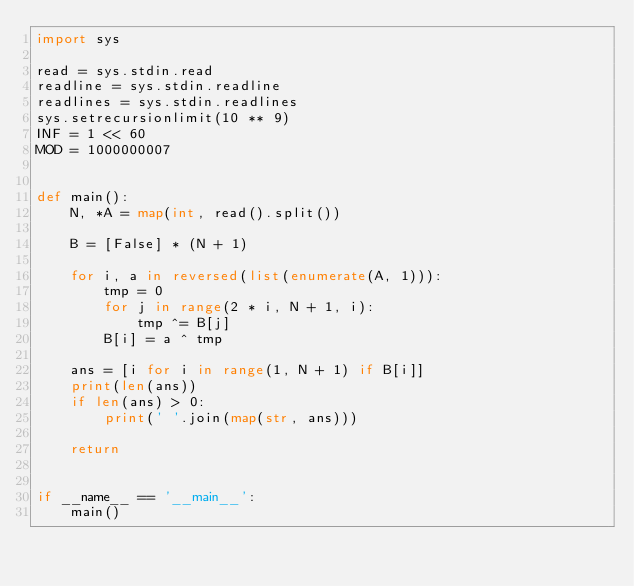<code> <loc_0><loc_0><loc_500><loc_500><_Python_>import sys

read = sys.stdin.read
readline = sys.stdin.readline
readlines = sys.stdin.readlines
sys.setrecursionlimit(10 ** 9)
INF = 1 << 60
MOD = 1000000007


def main():
    N, *A = map(int, read().split())

    B = [False] * (N + 1)

    for i, a in reversed(list(enumerate(A, 1))):
        tmp = 0
        for j in range(2 * i, N + 1, i):
            tmp ^= B[j]
        B[i] = a ^ tmp

    ans = [i for i in range(1, N + 1) if B[i]]
    print(len(ans))
    if len(ans) > 0:
        print(' '.join(map(str, ans)))

    return


if __name__ == '__main__':
    main()
</code> 